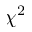<formula> <loc_0><loc_0><loc_500><loc_500>\chi ^ { 2 }</formula> 